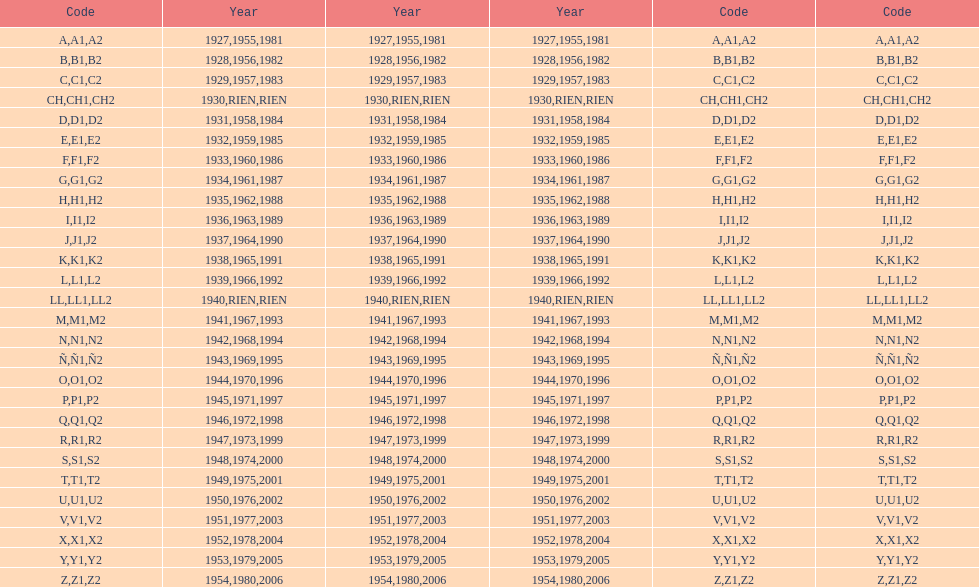List each code not associated to a year. CH1, CH2, LL1, LL2. 